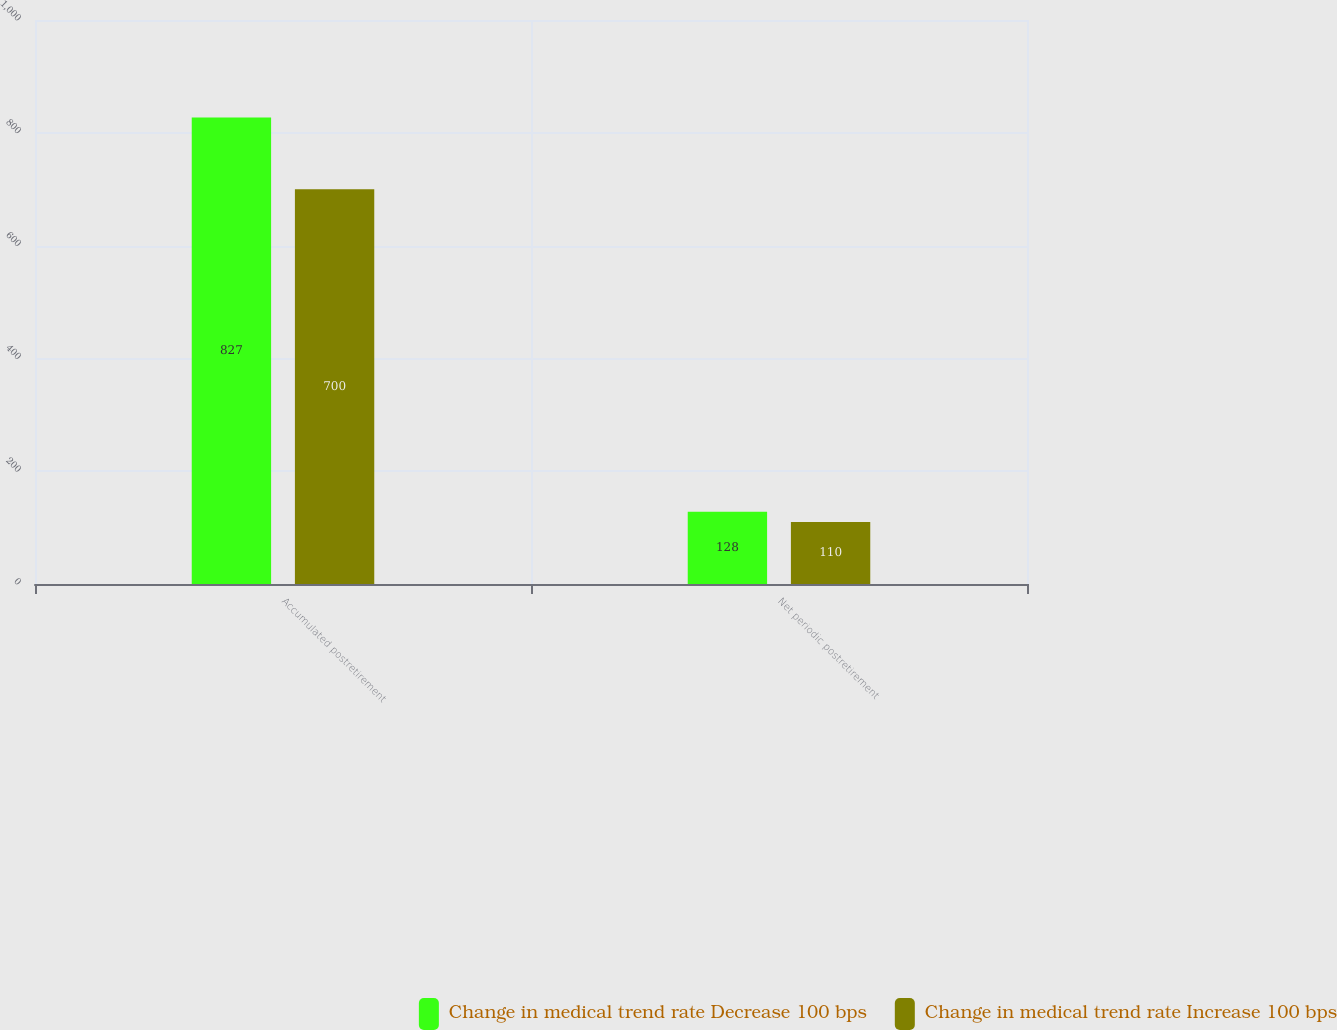Convert chart to OTSL. <chart><loc_0><loc_0><loc_500><loc_500><stacked_bar_chart><ecel><fcel>Accumulated postretirement<fcel>Net periodic postretirement<nl><fcel>Change in medical trend rate Decrease 100 bps<fcel>827<fcel>128<nl><fcel>Change in medical trend rate Increase 100 bps<fcel>700<fcel>110<nl></chart> 